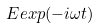<formula> <loc_0><loc_0><loc_500><loc_500>E e x p ( - i \omega t )</formula> 